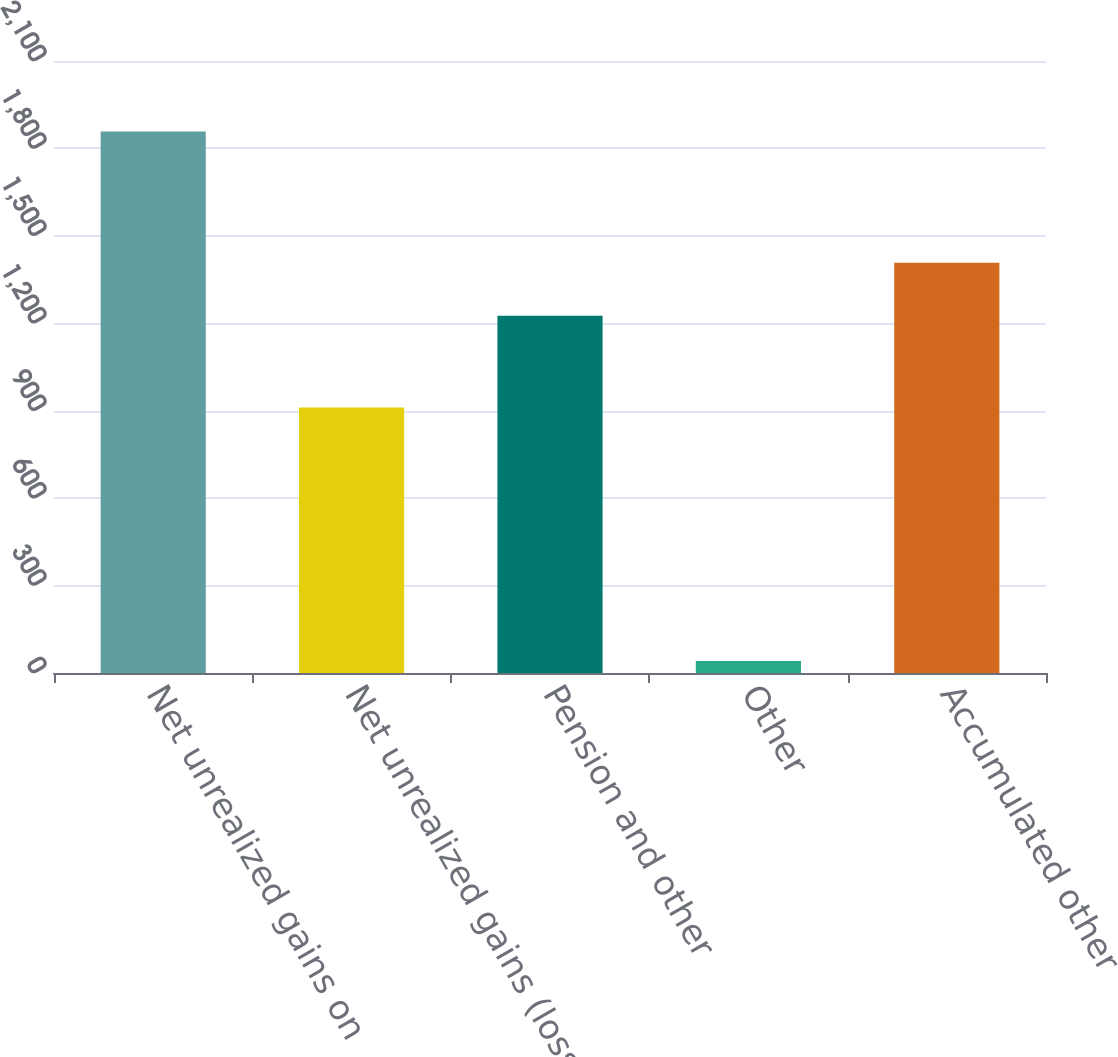<chart> <loc_0><loc_0><loc_500><loc_500><bar_chart><fcel>Net unrealized gains on<fcel>Net unrealized gains (losses)<fcel>Pension and other<fcel>Other<fcel>Accumulated other<nl><fcel>1858<fcel>911<fcel>1226<fcel>41<fcel>1407.7<nl></chart> 